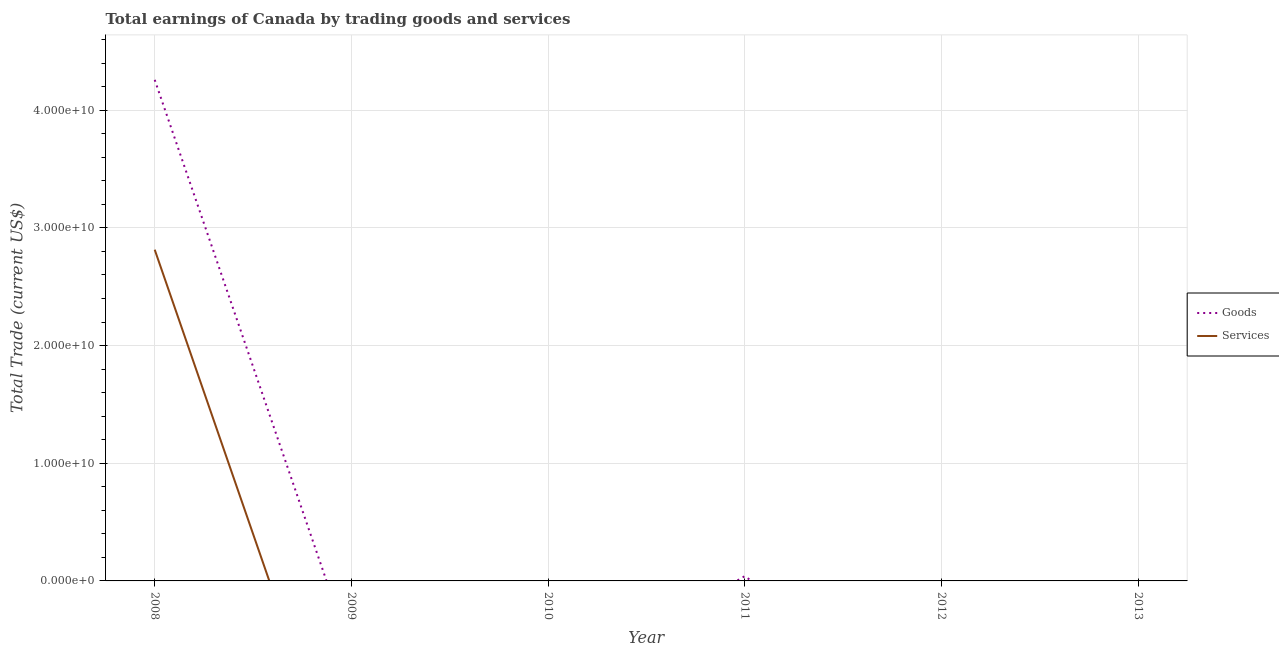Does the line corresponding to amount earned by trading goods intersect with the line corresponding to amount earned by trading services?
Offer a very short reply. No. What is the amount earned by trading goods in 2013?
Your response must be concise. 0. Across all years, what is the maximum amount earned by trading services?
Your answer should be compact. 2.81e+1. What is the total amount earned by trading services in the graph?
Keep it short and to the point. 2.81e+1. What is the difference between the amount earned by trading services in 2008 and the amount earned by trading goods in 2012?
Give a very brief answer. 2.81e+1. What is the average amount earned by trading services per year?
Keep it short and to the point. 4.69e+09. In the year 2008, what is the difference between the amount earned by trading services and amount earned by trading goods?
Make the answer very short. -1.44e+1. In how many years, is the amount earned by trading services greater than 26000000000 US$?
Your answer should be very brief. 1. What is the difference between the highest and the lowest amount earned by trading services?
Your answer should be very brief. 2.81e+1. In how many years, is the amount earned by trading services greater than the average amount earned by trading services taken over all years?
Your answer should be very brief. 1. Is the amount earned by trading services strictly greater than the amount earned by trading goods over the years?
Your answer should be compact. No. Is the amount earned by trading services strictly less than the amount earned by trading goods over the years?
Offer a very short reply. Yes. How many years are there in the graph?
Provide a succinct answer. 6. What is the difference between two consecutive major ticks on the Y-axis?
Provide a succinct answer. 1.00e+1. Are the values on the major ticks of Y-axis written in scientific E-notation?
Keep it short and to the point. Yes. How many legend labels are there?
Give a very brief answer. 2. How are the legend labels stacked?
Offer a very short reply. Vertical. What is the title of the graph?
Give a very brief answer. Total earnings of Canada by trading goods and services. Does "Investment" appear as one of the legend labels in the graph?
Your answer should be very brief. No. What is the label or title of the X-axis?
Make the answer very short. Year. What is the label or title of the Y-axis?
Make the answer very short. Total Trade (current US$). What is the Total Trade (current US$) in Goods in 2008?
Your answer should be very brief. 4.26e+1. What is the Total Trade (current US$) in Services in 2008?
Your response must be concise. 2.81e+1. What is the Total Trade (current US$) of Services in 2009?
Offer a very short reply. 0. What is the Total Trade (current US$) of Goods in 2010?
Keep it short and to the point. 0. What is the Total Trade (current US$) of Goods in 2011?
Your response must be concise. 4.03e+08. What is the Total Trade (current US$) of Services in 2012?
Provide a succinct answer. 0. What is the Total Trade (current US$) in Services in 2013?
Offer a terse response. 0. Across all years, what is the maximum Total Trade (current US$) in Goods?
Offer a terse response. 4.26e+1. Across all years, what is the maximum Total Trade (current US$) in Services?
Your response must be concise. 2.81e+1. Across all years, what is the minimum Total Trade (current US$) of Services?
Ensure brevity in your answer.  0. What is the total Total Trade (current US$) in Goods in the graph?
Your response must be concise. 4.30e+1. What is the total Total Trade (current US$) of Services in the graph?
Your answer should be compact. 2.81e+1. What is the difference between the Total Trade (current US$) in Goods in 2008 and that in 2011?
Offer a very short reply. 4.22e+1. What is the average Total Trade (current US$) in Goods per year?
Give a very brief answer. 7.16e+09. What is the average Total Trade (current US$) in Services per year?
Make the answer very short. 4.69e+09. In the year 2008, what is the difference between the Total Trade (current US$) of Goods and Total Trade (current US$) of Services?
Keep it short and to the point. 1.44e+1. What is the ratio of the Total Trade (current US$) of Goods in 2008 to that in 2011?
Your answer should be very brief. 105.55. What is the difference between the highest and the lowest Total Trade (current US$) in Goods?
Your response must be concise. 4.26e+1. What is the difference between the highest and the lowest Total Trade (current US$) in Services?
Keep it short and to the point. 2.81e+1. 